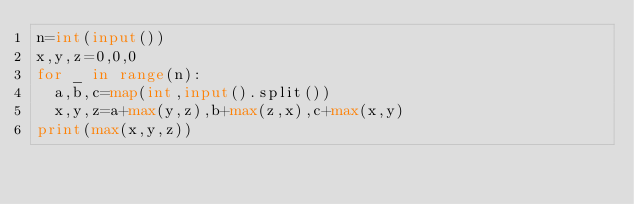Convert code to text. <code><loc_0><loc_0><loc_500><loc_500><_Python_>n=int(input())
x,y,z=0,0,0
for _ in range(n):
  a,b,c=map(int,input().split())
  x,y,z=a+max(y,z),b+max(z,x),c+max(x,y)
print(max(x,y,z))</code> 